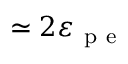<formula> <loc_0><loc_0><loc_500><loc_500>\simeq 2 \varepsilon _ { p e }</formula> 